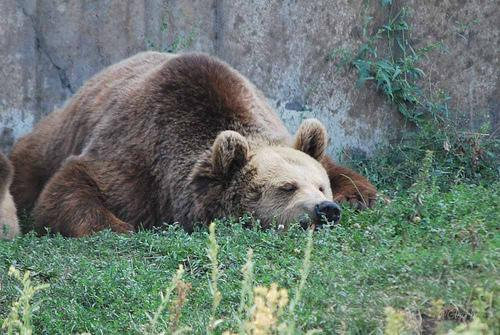Question: who is in the photo?
Choices:
A. A woman.
B. A man.
C. A giriffe.
D. No one.
Answer with the letter. Answer: D Question: what animal is there?
Choices:
A. Lion.
B. Tiger.
C. Gorilla.
D. Bear.
Answer with the letter. Answer: D Question: where was the photo taken?
Choices:
A. Park.
B. Beach.
C. School.
D. Restaurant.
Answer with the letter. Answer: A Question: what type of scene is this?
Choices:
A. Indoor.
B. Ocean.
C. Outdoor.
D. Mountainous.
Answer with the letter. Answer: C 